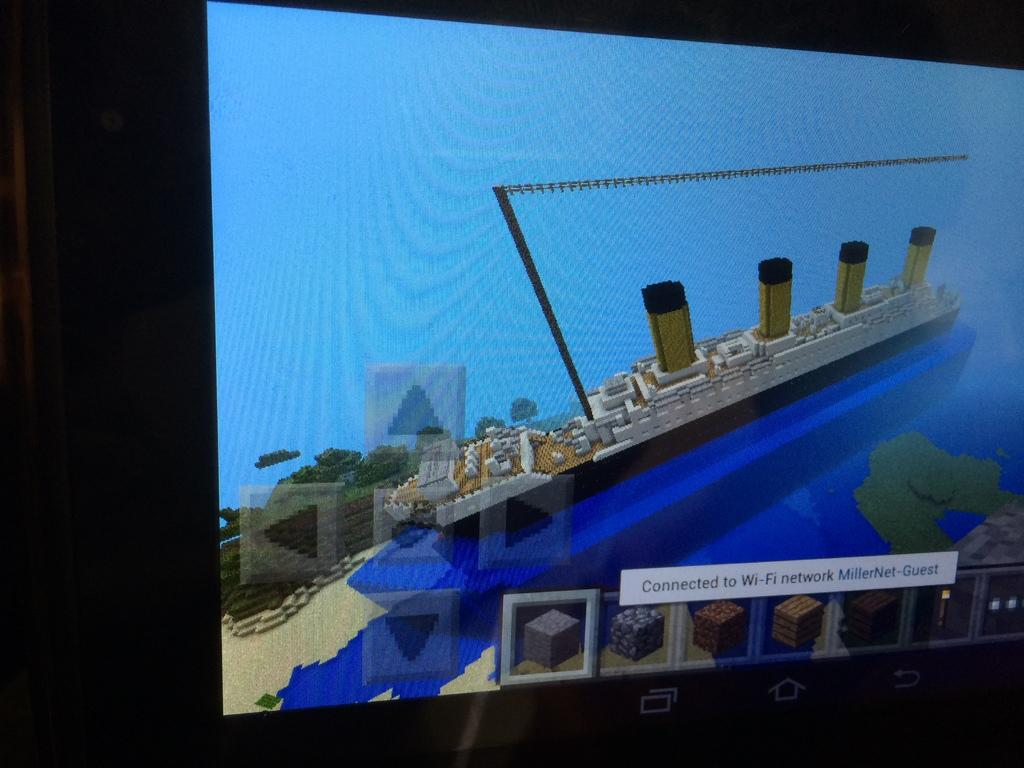What type of image is being described? The image is an animated screenshot. What is the main subject in the image? There is a ship in the image. How is the ship positioned in the image? The ship is floating on water. Is there any text present in the image? Yes, there is text visible in the image. What type of brush is being used to paint the ship in the image? There is no brush present in the image, as it is an animated screenshot and not a painting. How many feet are visible on the ship in the image? There are no feet visible in the image, as it features a ship floating on water and not people or animals. 